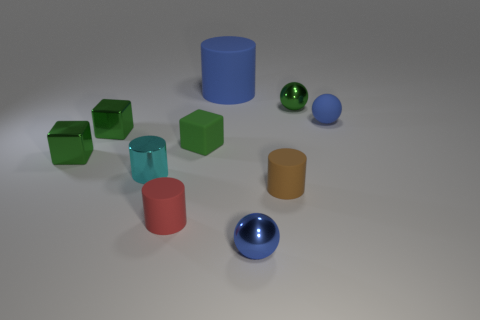How many green blocks must be subtracted to get 1 green blocks? 2 Subtract all blue cylinders. How many blue balls are left? 2 Subtract 2 cylinders. How many cylinders are left? 2 Subtract all tiny matte cubes. How many cubes are left? 2 Subtract all green spheres. How many spheres are left? 2 Subtract 0 yellow blocks. How many objects are left? 10 Subtract all cylinders. How many objects are left? 6 Subtract all green cylinders. Subtract all gray spheres. How many cylinders are left? 4 Subtract all tiny cyan cylinders. Subtract all large rubber spheres. How many objects are left? 9 Add 3 small blue metallic spheres. How many small blue metallic spheres are left? 4 